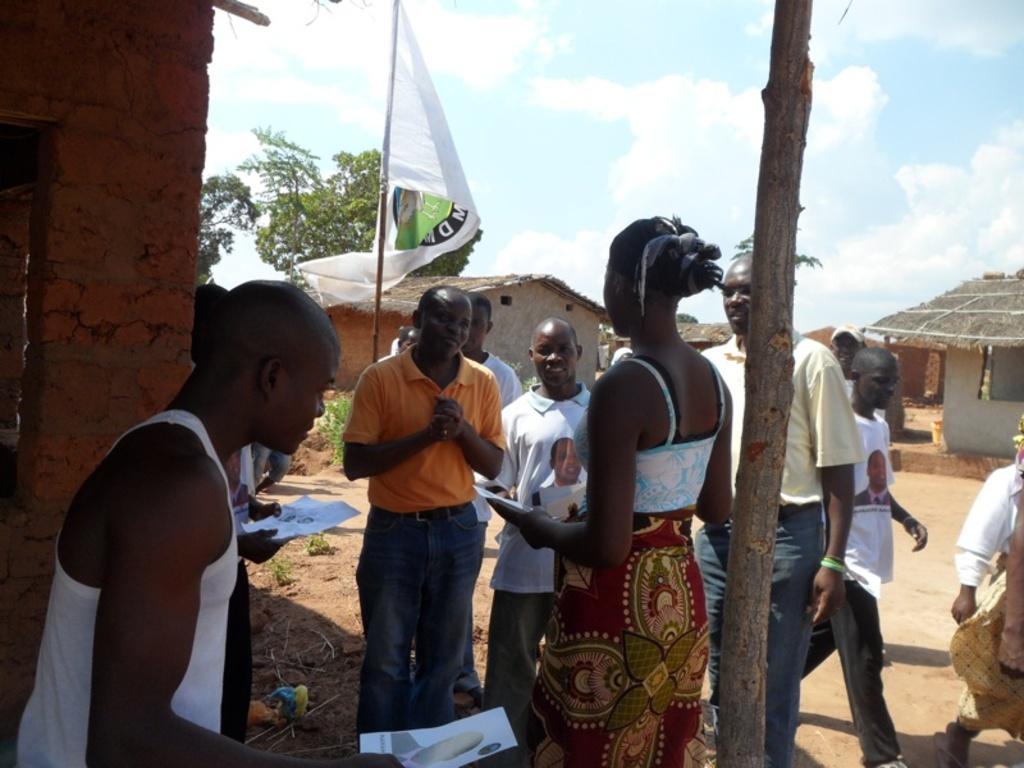Can you describe this image briefly? In this image I see number of people and I see a flag over here and I see the papers in hands. In the background I see the huts, a wooden pole over here and I see the ground, trees and the sky. 